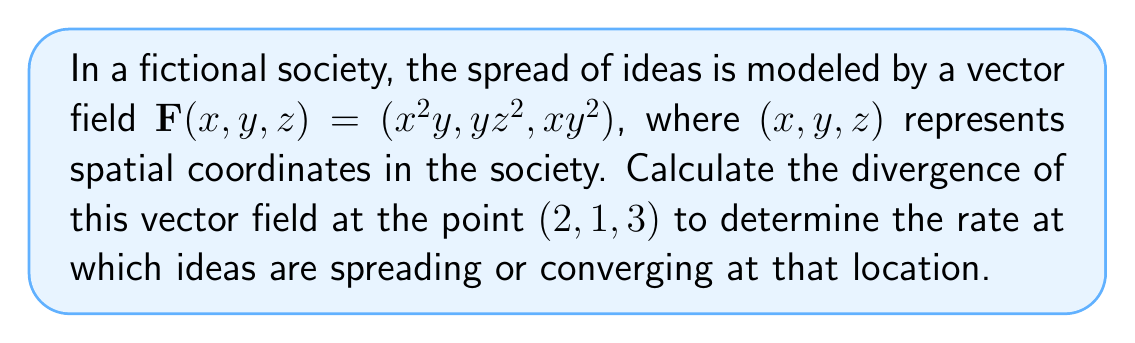Can you solve this math problem? To solve this problem, we need to follow these steps:

1) The divergence of a vector field $\mathbf{F}(x, y, z) = (F_1, F_2, F_3)$ is given by:

   $$\nabla \cdot \mathbf{F} = \frac{\partial F_1}{\partial x} + \frac{\partial F_2}{\partial y} + \frac{\partial F_3}{\partial z}$$

2) For our vector field $\mathbf{F}(x, y, z) = (x^2y, yz^2, xy^2)$, we have:
   $F_1 = x^2y$
   $F_2 = yz^2$
   $F_3 = xy^2$

3) Now, let's calculate each partial derivative:

   $\frac{\partial F_1}{\partial x} = \frac{\partial}{\partial x}(x^2y) = 2xy$

   $\frac{\partial F_2}{\partial y} = \frac{\partial}{\partial y}(yz^2) = z^2$

   $\frac{\partial F_3}{\partial z} = \frac{\partial}{\partial z}(xy^2) = 0$

4) The divergence is the sum of these partial derivatives:

   $$\nabla \cdot \mathbf{F} = 2xy + z^2 + 0 = 2xy + z^2$$

5) To find the divergence at the point (2, 1, 3), we substitute these values:

   $$\nabla \cdot \mathbf{F}|_{(2,1,3)} = 2(2)(1) + 3^2 = 4 + 9 = 13$$

Therefore, the divergence of the vector field at the point (2, 1, 3) is 13.
Answer: 13 